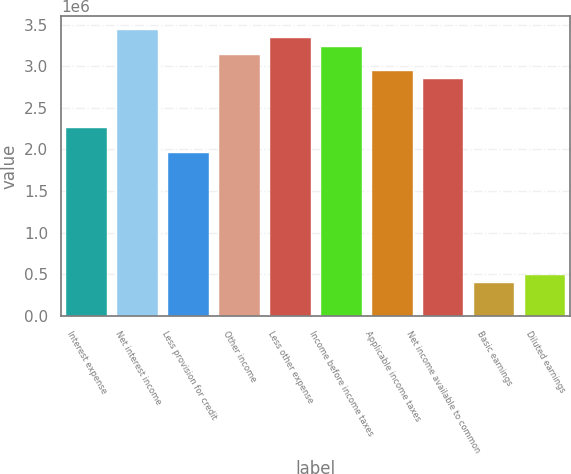Convert chart. <chart><loc_0><loc_0><loc_500><loc_500><bar_chart><fcel>Interest expense<fcel>Net interest income<fcel>Less provision for credit<fcel>Other income<fcel>Less other expense<fcel>Income before income taxes<fcel>Applicable income taxes<fcel>Net income available to common<fcel>Basic earnings<fcel>Diluted earnings<nl><fcel>2.25505e+06<fcel>3.4316e+06<fcel>1.96091e+06<fcel>3.13746e+06<fcel>3.33355e+06<fcel>3.23551e+06<fcel>2.94137e+06<fcel>2.84332e+06<fcel>392183<fcel>490229<nl></chart> 